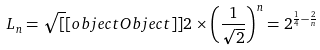<formula> <loc_0><loc_0><loc_500><loc_500>L _ { n } = { \sqrt { [ } [ o b j e c t O b j e c t ] ] { 2 } } \times \left ( { \frac { 1 } { \sqrt { 2 } } } \right ) ^ { n } = 2 ^ { { \frac { 1 } { 4 } } - { \frac { 2 } { n } } }</formula> 